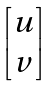Convert formula to latex. <formula><loc_0><loc_0><loc_500><loc_500>\begin{bmatrix} u \\ v \end{bmatrix}</formula> 